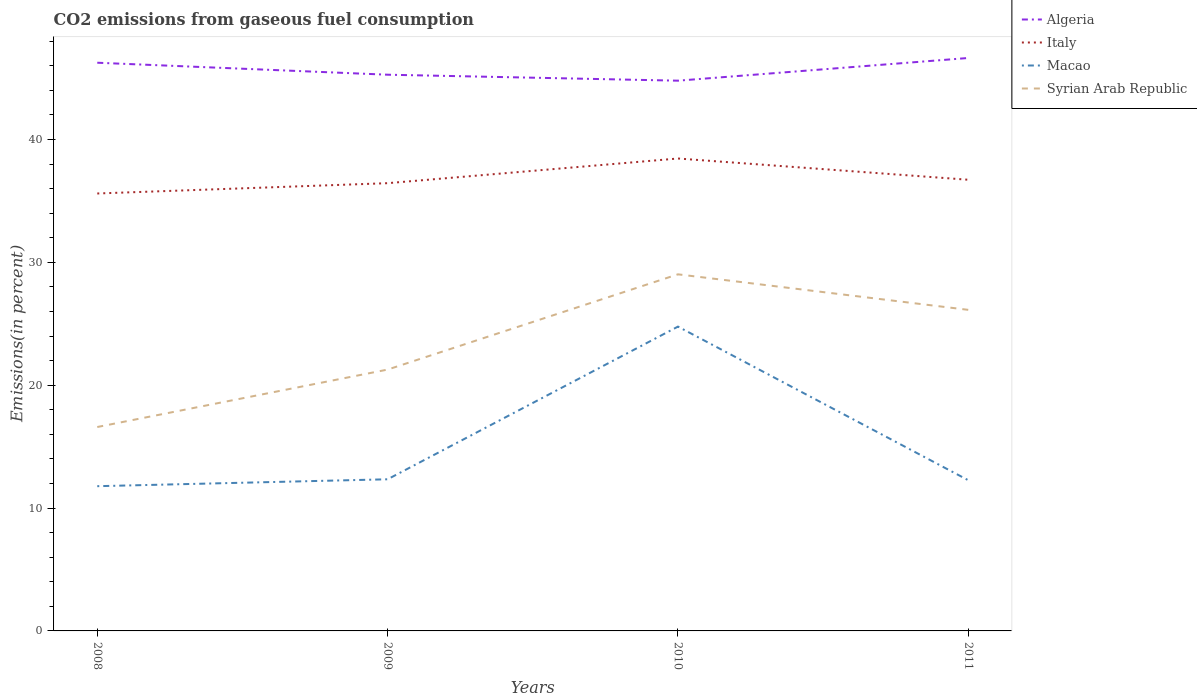Does the line corresponding to Italy intersect with the line corresponding to Algeria?
Ensure brevity in your answer.  No. Is the number of lines equal to the number of legend labels?
Ensure brevity in your answer.  Yes. Across all years, what is the maximum total CO2 emitted in Italy?
Offer a very short reply. 35.61. What is the total total CO2 emitted in Algeria in the graph?
Provide a short and direct response. -1.36. What is the difference between the highest and the second highest total CO2 emitted in Italy?
Your answer should be very brief. 2.85. What is the difference between the highest and the lowest total CO2 emitted in Algeria?
Provide a succinct answer. 2. Is the total CO2 emitted in Italy strictly greater than the total CO2 emitted in Syrian Arab Republic over the years?
Your answer should be compact. No. How many lines are there?
Make the answer very short. 4. How many years are there in the graph?
Your answer should be compact. 4. What is the difference between two consecutive major ticks on the Y-axis?
Offer a terse response. 10. Does the graph contain grids?
Your answer should be very brief. No. Where does the legend appear in the graph?
Make the answer very short. Top right. How many legend labels are there?
Offer a terse response. 4. How are the legend labels stacked?
Your answer should be compact. Vertical. What is the title of the graph?
Make the answer very short. CO2 emissions from gaseous fuel consumption. What is the label or title of the X-axis?
Make the answer very short. Years. What is the label or title of the Y-axis?
Offer a terse response. Emissions(in percent). What is the Emissions(in percent) in Algeria in 2008?
Your answer should be compact. 46.25. What is the Emissions(in percent) of Italy in 2008?
Your response must be concise. 35.61. What is the Emissions(in percent) of Macao in 2008?
Provide a succinct answer. 11.78. What is the Emissions(in percent) in Syrian Arab Republic in 2008?
Your response must be concise. 16.6. What is the Emissions(in percent) in Algeria in 2009?
Your answer should be compact. 45.27. What is the Emissions(in percent) of Italy in 2009?
Your response must be concise. 36.44. What is the Emissions(in percent) of Macao in 2009?
Offer a terse response. 12.34. What is the Emissions(in percent) of Syrian Arab Republic in 2009?
Keep it short and to the point. 21.27. What is the Emissions(in percent) of Algeria in 2010?
Your response must be concise. 44.79. What is the Emissions(in percent) of Italy in 2010?
Offer a very short reply. 38.45. What is the Emissions(in percent) in Macao in 2010?
Provide a succinct answer. 24.77. What is the Emissions(in percent) in Syrian Arab Republic in 2010?
Keep it short and to the point. 29.03. What is the Emissions(in percent) in Algeria in 2011?
Make the answer very short. 46.63. What is the Emissions(in percent) of Italy in 2011?
Your response must be concise. 36.72. What is the Emissions(in percent) in Macao in 2011?
Keep it short and to the point. 12.26. What is the Emissions(in percent) in Syrian Arab Republic in 2011?
Offer a very short reply. 26.13. Across all years, what is the maximum Emissions(in percent) of Algeria?
Your answer should be very brief. 46.63. Across all years, what is the maximum Emissions(in percent) in Italy?
Keep it short and to the point. 38.45. Across all years, what is the maximum Emissions(in percent) of Macao?
Your answer should be very brief. 24.77. Across all years, what is the maximum Emissions(in percent) of Syrian Arab Republic?
Provide a short and direct response. 29.03. Across all years, what is the minimum Emissions(in percent) in Algeria?
Provide a short and direct response. 44.79. Across all years, what is the minimum Emissions(in percent) in Italy?
Your response must be concise. 35.61. Across all years, what is the minimum Emissions(in percent) in Macao?
Offer a very short reply. 11.78. Across all years, what is the minimum Emissions(in percent) in Syrian Arab Republic?
Provide a succinct answer. 16.6. What is the total Emissions(in percent) in Algeria in the graph?
Provide a short and direct response. 182.94. What is the total Emissions(in percent) of Italy in the graph?
Your answer should be very brief. 147.23. What is the total Emissions(in percent) in Macao in the graph?
Your answer should be very brief. 61.16. What is the total Emissions(in percent) of Syrian Arab Republic in the graph?
Provide a short and direct response. 93.03. What is the difference between the Emissions(in percent) in Algeria in 2008 and that in 2009?
Your response must be concise. 0.98. What is the difference between the Emissions(in percent) in Italy in 2008 and that in 2009?
Make the answer very short. -0.84. What is the difference between the Emissions(in percent) in Macao in 2008 and that in 2009?
Provide a short and direct response. -0.56. What is the difference between the Emissions(in percent) of Syrian Arab Republic in 2008 and that in 2009?
Give a very brief answer. -4.68. What is the difference between the Emissions(in percent) in Algeria in 2008 and that in 2010?
Make the answer very short. 1.46. What is the difference between the Emissions(in percent) in Italy in 2008 and that in 2010?
Provide a short and direct response. -2.85. What is the difference between the Emissions(in percent) in Macao in 2008 and that in 2010?
Give a very brief answer. -12.99. What is the difference between the Emissions(in percent) of Syrian Arab Republic in 2008 and that in 2010?
Ensure brevity in your answer.  -12.43. What is the difference between the Emissions(in percent) in Algeria in 2008 and that in 2011?
Your answer should be very brief. -0.39. What is the difference between the Emissions(in percent) in Italy in 2008 and that in 2011?
Ensure brevity in your answer.  -1.12. What is the difference between the Emissions(in percent) in Macao in 2008 and that in 2011?
Keep it short and to the point. -0.48. What is the difference between the Emissions(in percent) of Syrian Arab Republic in 2008 and that in 2011?
Give a very brief answer. -9.54. What is the difference between the Emissions(in percent) of Algeria in 2009 and that in 2010?
Your answer should be very brief. 0.49. What is the difference between the Emissions(in percent) in Italy in 2009 and that in 2010?
Your answer should be compact. -2.01. What is the difference between the Emissions(in percent) in Macao in 2009 and that in 2010?
Provide a succinct answer. -12.43. What is the difference between the Emissions(in percent) in Syrian Arab Republic in 2009 and that in 2010?
Your answer should be very brief. -7.75. What is the difference between the Emissions(in percent) of Algeria in 2009 and that in 2011?
Provide a succinct answer. -1.36. What is the difference between the Emissions(in percent) of Italy in 2009 and that in 2011?
Your answer should be compact. -0.28. What is the difference between the Emissions(in percent) in Macao in 2009 and that in 2011?
Offer a terse response. 0.08. What is the difference between the Emissions(in percent) in Syrian Arab Republic in 2009 and that in 2011?
Give a very brief answer. -4.86. What is the difference between the Emissions(in percent) in Algeria in 2010 and that in 2011?
Offer a very short reply. -1.85. What is the difference between the Emissions(in percent) of Italy in 2010 and that in 2011?
Provide a short and direct response. 1.73. What is the difference between the Emissions(in percent) in Macao in 2010 and that in 2011?
Give a very brief answer. 12.51. What is the difference between the Emissions(in percent) in Syrian Arab Republic in 2010 and that in 2011?
Your response must be concise. 2.89. What is the difference between the Emissions(in percent) of Algeria in 2008 and the Emissions(in percent) of Italy in 2009?
Your response must be concise. 9.8. What is the difference between the Emissions(in percent) of Algeria in 2008 and the Emissions(in percent) of Macao in 2009?
Ensure brevity in your answer.  33.91. What is the difference between the Emissions(in percent) in Algeria in 2008 and the Emissions(in percent) in Syrian Arab Republic in 2009?
Provide a succinct answer. 24.98. What is the difference between the Emissions(in percent) in Italy in 2008 and the Emissions(in percent) in Macao in 2009?
Offer a very short reply. 23.26. What is the difference between the Emissions(in percent) in Italy in 2008 and the Emissions(in percent) in Syrian Arab Republic in 2009?
Make the answer very short. 14.33. What is the difference between the Emissions(in percent) of Macao in 2008 and the Emissions(in percent) of Syrian Arab Republic in 2009?
Offer a terse response. -9.49. What is the difference between the Emissions(in percent) in Algeria in 2008 and the Emissions(in percent) in Italy in 2010?
Your answer should be compact. 7.8. What is the difference between the Emissions(in percent) of Algeria in 2008 and the Emissions(in percent) of Macao in 2010?
Keep it short and to the point. 21.48. What is the difference between the Emissions(in percent) in Algeria in 2008 and the Emissions(in percent) in Syrian Arab Republic in 2010?
Your answer should be compact. 17.22. What is the difference between the Emissions(in percent) of Italy in 2008 and the Emissions(in percent) of Macao in 2010?
Your response must be concise. 10.83. What is the difference between the Emissions(in percent) in Italy in 2008 and the Emissions(in percent) in Syrian Arab Republic in 2010?
Your response must be concise. 6.58. What is the difference between the Emissions(in percent) in Macao in 2008 and the Emissions(in percent) in Syrian Arab Republic in 2010?
Your answer should be compact. -17.24. What is the difference between the Emissions(in percent) of Algeria in 2008 and the Emissions(in percent) of Italy in 2011?
Offer a very short reply. 9.53. What is the difference between the Emissions(in percent) in Algeria in 2008 and the Emissions(in percent) in Macao in 2011?
Keep it short and to the point. 33.98. What is the difference between the Emissions(in percent) of Algeria in 2008 and the Emissions(in percent) of Syrian Arab Republic in 2011?
Give a very brief answer. 20.11. What is the difference between the Emissions(in percent) in Italy in 2008 and the Emissions(in percent) in Macao in 2011?
Keep it short and to the point. 23.34. What is the difference between the Emissions(in percent) of Italy in 2008 and the Emissions(in percent) of Syrian Arab Republic in 2011?
Your answer should be compact. 9.47. What is the difference between the Emissions(in percent) of Macao in 2008 and the Emissions(in percent) of Syrian Arab Republic in 2011?
Provide a succinct answer. -14.35. What is the difference between the Emissions(in percent) in Algeria in 2009 and the Emissions(in percent) in Italy in 2010?
Ensure brevity in your answer.  6.82. What is the difference between the Emissions(in percent) of Algeria in 2009 and the Emissions(in percent) of Macao in 2010?
Your response must be concise. 20.5. What is the difference between the Emissions(in percent) in Algeria in 2009 and the Emissions(in percent) in Syrian Arab Republic in 2010?
Give a very brief answer. 16.25. What is the difference between the Emissions(in percent) in Italy in 2009 and the Emissions(in percent) in Macao in 2010?
Provide a short and direct response. 11.67. What is the difference between the Emissions(in percent) in Italy in 2009 and the Emissions(in percent) in Syrian Arab Republic in 2010?
Your answer should be compact. 7.42. What is the difference between the Emissions(in percent) in Macao in 2009 and the Emissions(in percent) in Syrian Arab Republic in 2010?
Your response must be concise. -16.68. What is the difference between the Emissions(in percent) in Algeria in 2009 and the Emissions(in percent) in Italy in 2011?
Offer a very short reply. 8.55. What is the difference between the Emissions(in percent) in Algeria in 2009 and the Emissions(in percent) in Macao in 2011?
Offer a terse response. 33.01. What is the difference between the Emissions(in percent) in Algeria in 2009 and the Emissions(in percent) in Syrian Arab Republic in 2011?
Give a very brief answer. 19.14. What is the difference between the Emissions(in percent) in Italy in 2009 and the Emissions(in percent) in Macao in 2011?
Give a very brief answer. 24.18. What is the difference between the Emissions(in percent) in Italy in 2009 and the Emissions(in percent) in Syrian Arab Republic in 2011?
Ensure brevity in your answer.  10.31. What is the difference between the Emissions(in percent) of Macao in 2009 and the Emissions(in percent) of Syrian Arab Republic in 2011?
Provide a succinct answer. -13.79. What is the difference between the Emissions(in percent) in Algeria in 2010 and the Emissions(in percent) in Italy in 2011?
Your answer should be very brief. 8.06. What is the difference between the Emissions(in percent) in Algeria in 2010 and the Emissions(in percent) in Macao in 2011?
Give a very brief answer. 32.52. What is the difference between the Emissions(in percent) in Algeria in 2010 and the Emissions(in percent) in Syrian Arab Republic in 2011?
Provide a short and direct response. 18.65. What is the difference between the Emissions(in percent) of Italy in 2010 and the Emissions(in percent) of Macao in 2011?
Your answer should be compact. 26.19. What is the difference between the Emissions(in percent) of Italy in 2010 and the Emissions(in percent) of Syrian Arab Republic in 2011?
Your answer should be compact. 12.32. What is the difference between the Emissions(in percent) of Macao in 2010 and the Emissions(in percent) of Syrian Arab Republic in 2011?
Offer a very short reply. -1.36. What is the average Emissions(in percent) of Algeria per year?
Your answer should be very brief. 45.74. What is the average Emissions(in percent) in Italy per year?
Offer a terse response. 36.81. What is the average Emissions(in percent) in Macao per year?
Provide a succinct answer. 15.29. What is the average Emissions(in percent) of Syrian Arab Republic per year?
Provide a short and direct response. 23.26. In the year 2008, what is the difference between the Emissions(in percent) of Algeria and Emissions(in percent) of Italy?
Offer a terse response. 10.64. In the year 2008, what is the difference between the Emissions(in percent) in Algeria and Emissions(in percent) in Macao?
Ensure brevity in your answer.  34.47. In the year 2008, what is the difference between the Emissions(in percent) of Algeria and Emissions(in percent) of Syrian Arab Republic?
Give a very brief answer. 29.65. In the year 2008, what is the difference between the Emissions(in percent) of Italy and Emissions(in percent) of Macao?
Ensure brevity in your answer.  23.82. In the year 2008, what is the difference between the Emissions(in percent) of Italy and Emissions(in percent) of Syrian Arab Republic?
Your answer should be compact. 19.01. In the year 2008, what is the difference between the Emissions(in percent) in Macao and Emissions(in percent) in Syrian Arab Republic?
Ensure brevity in your answer.  -4.82. In the year 2009, what is the difference between the Emissions(in percent) of Algeria and Emissions(in percent) of Italy?
Provide a succinct answer. 8.83. In the year 2009, what is the difference between the Emissions(in percent) of Algeria and Emissions(in percent) of Macao?
Ensure brevity in your answer.  32.93. In the year 2009, what is the difference between the Emissions(in percent) in Algeria and Emissions(in percent) in Syrian Arab Republic?
Your answer should be compact. 24. In the year 2009, what is the difference between the Emissions(in percent) of Italy and Emissions(in percent) of Macao?
Your answer should be very brief. 24.1. In the year 2009, what is the difference between the Emissions(in percent) of Italy and Emissions(in percent) of Syrian Arab Republic?
Provide a short and direct response. 15.17. In the year 2009, what is the difference between the Emissions(in percent) of Macao and Emissions(in percent) of Syrian Arab Republic?
Offer a terse response. -8.93. In the year 2010, what is the difference between the Emissions(in percent) of Algeria and Emissions(in percent) of Italy?
Keep it short and to the point. 6.33. In the year 2010, what is the difference between the Emissions(in percent) of Algeria and Emissions(in percent) of Macao?
Ensure brevity in your answer.  20.02. In the year 2010, what is the difference between the Emissions(in percent) in Algeria and Emissions(in percent) in Syrian Arab Republic?
Make the answer very short. 15.76. In the year 2010, what is the difference between the Emissions(in percent) of Italy and Emissions(in percent) of Macao?
Keep it short and to the point. 13.68. In the year 2010, what is the difference between the Emissions(in percent) in Italy and Emissions(in percent) in Syrian Arab Republic?
Your answer should be very brief. 9.43. In the year 2010, what is the difference between the Emissions(in percent) in Macao and Emissions(in percent) in Syrian Arab Republic?
Ensure brevity in your answer.  -4.26. In the year 2011, what is the difference between the Emissions(in percent) of Algeria and Emissions(in percent) of Italy?
Give a very brief answer. 9.91. In the year 2011, what is the difference between the Emissions(in percent) in Algeria and Emissions(in percent) in Macao?
Provide a short and direct response. 34.37. In the year 2011, what is the difference between the Emissions(in percent) of Algeria and Emissions(in percent) of Syrian Arab Republic?
Your answer should be compact. 20.5. In the year 2011, what is the difference between the Emissions(in percent) in Italy and Emissions(in percent) in Macao?
Provide a short and direct response. 24.46. In the year 2011, what is the difference between the Emissions(in percent) in Italy and Emissions(in percent) in Syrian Arab Republic?
Offer a very short reply. 10.59. In the year 2011, what is the difference between the Emissions(in percent) in Macao and Emissions(in percent) in Syrian Arab Republic?
Keep it short and to the point. -13.87. What is the ratio of the Emissions(in percent) in Algeria in 2008 to that in 2009?
Offer a very short reply. 1.02. What is the ratio of the Emissions(in percent) of Macao in 2008 to that in 2009?
Give a very brief answer. 0.95. What is the ratio of the Emissions(in percent) in Syrian Arab Republic in 2008 to that in 2009?
Make the answer very short. 0.78. What is the ratio of the Emissions(in percent) in Algeria in 2008 to that in 2010?
Your response must be concise. 1.03. What is the ratio of the Emissions(in percent) of Italy in 2008 to that in 2010?
Your answer should be compact. 0.93. What is the ratio of the Emissions(in percent) of Macao in 2008 to that in 2010?
Ensure brevity in your answer.  0.48. What is the ratio of the Emissions(in percent) of Syrian Arab Republic in 2008 to that in 2010?
Make the answer very short. 0.57. What is the ratio of the Emissions(in percent) in Italy in 2008 to that in 2011?
Your answer should be very brief. 0.97. What is the ratio of the Emissions(in percent) in Macao in 2008 to that in 2011?
Make the answer very short. 0.96. What is the ratio of the Emissions(in percent) in Syrian Arab Republic in 2008 to that in 2011?
Offer a terse response. 0.64. What is the ratio of the Emissions(in percent) in Algeria in 2009 to that in 2010?
Your answer should be compact. 1.01. What is the ratio of the Emissions(in percent) of Italy in 2009 to that in 2010?
Keep it short and to the point. 0.95. What is the ratio of the Emissions(in percent) of Macao in 2009 to that in 2010?
Provide a succinct answer. 0.5. What is the ratio of the Emissions(in percent) in Syrian Arab Republic in 2009 to that in 2010?
Offer a terse response. 0.73. What is the ratio of the Emissions(in percent) of Algeria in 2009 to that in 2011?
Ensure brevity in your answer.  0.97. What is the ratio of the Emissions(in percent) in Italy in 2009 to that in 2011?
Your answer should be compact. 0.99. What is the ratio of the Emissions(in percent) of Macao in 2009 to that in 2011?
Keep it short and to the point. 1.01. What is the ratio of the Emissions(in percent) of Syrian Arab Republic in 2009 to that in 2011?
Offer a very short reply. 0.81. What is the ratio of the Emissions(in percent) in Algeria in 2010 to that in 2011?
Offer a terse response. 0.96. What is the ratio of the Emissions(in percent) of Italy in 2010 to that in 2011?
Provide a short and direct response. 1.05. What is the ratio of the Emissions(in percent) of Macao in 2010 to that in 2011?
Ensure brevity in your answer.  2.02. What is the ratio of the Emissions(in percent) of Syrian Arab Republic in 2010 to that in 2011?
Keep it short and to the point. 1.11. What is the difference between the highest and the second highest Emissions(in percent) in Algeria?
Your response must be concise. 0.39. What is the difference between the highest and the second highest Emissions(in percent) of Italy?
Provide a succinct answer. 1.73. What is the difference between the highest and the second highest Emissions(in percent) of Macao?
Your answer should be very brief. 12.43. What is the difference between the highest and the second highest Emissions(in percent) in Syrian Arab Republic?
Make the answer very short. 2.89. What is the difference between the highest and the lowest Emissions(in percent) in Algeria?
Your answer should be compact. 1.85. What is the difference between the highest and the lowest Emissions(in percent) of Italy?
Offer a very short reply. 2.85. What is the difference between the highest and the lowest Emissions(in percent) of Macao?
Your response must be concise. 12.99. What is the difference between the highest and the lowest Emissions(in percent) in Syrian Arab Republic?
Your answer should be very brief. 12.43. 